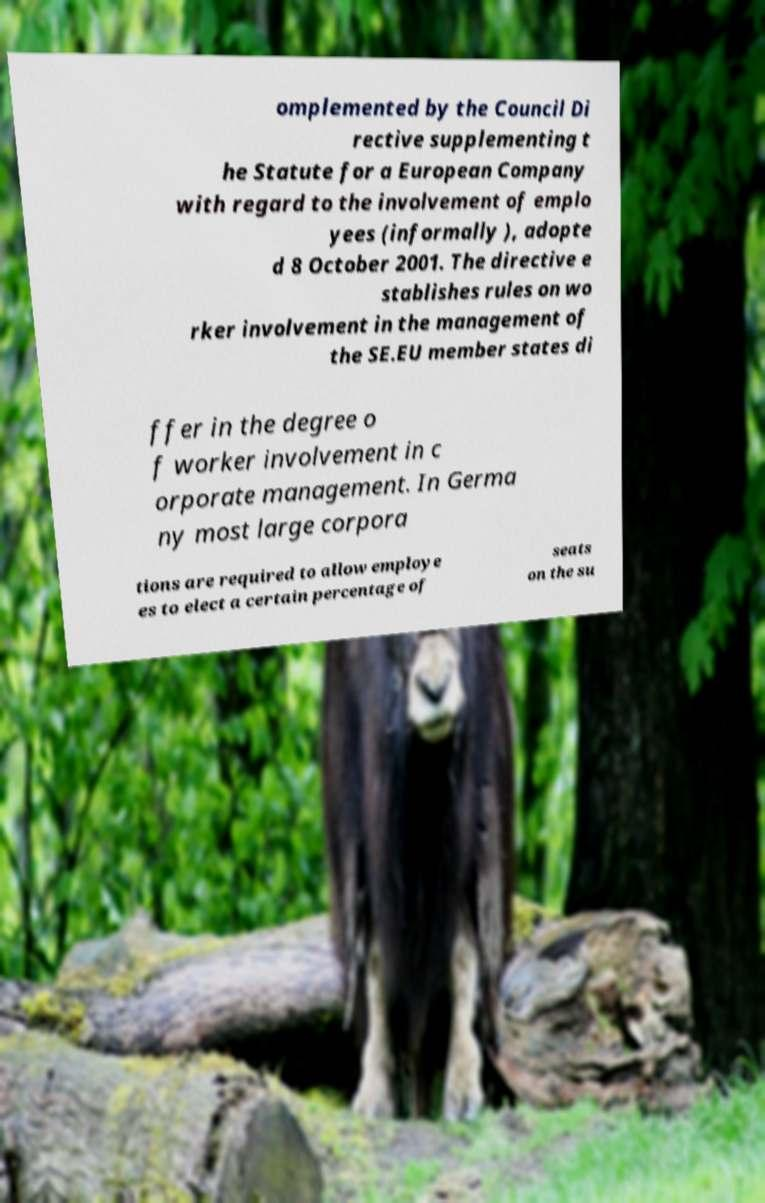Could you extract and type out the text from this image? omplemented by the Council Di rective supplementing t he Statute for a European Company with regard to the involvement of emplo yees (informally ), adopte d 8 October 2001. The directive e stablishes rules on wo rker involvement in the management of the SE.EU member states di ffer in the degree o f worker involvement in c orporate management. In Germa ny most large corpora tions are required to allow employe es to elect a certain percentage of seats on the su 